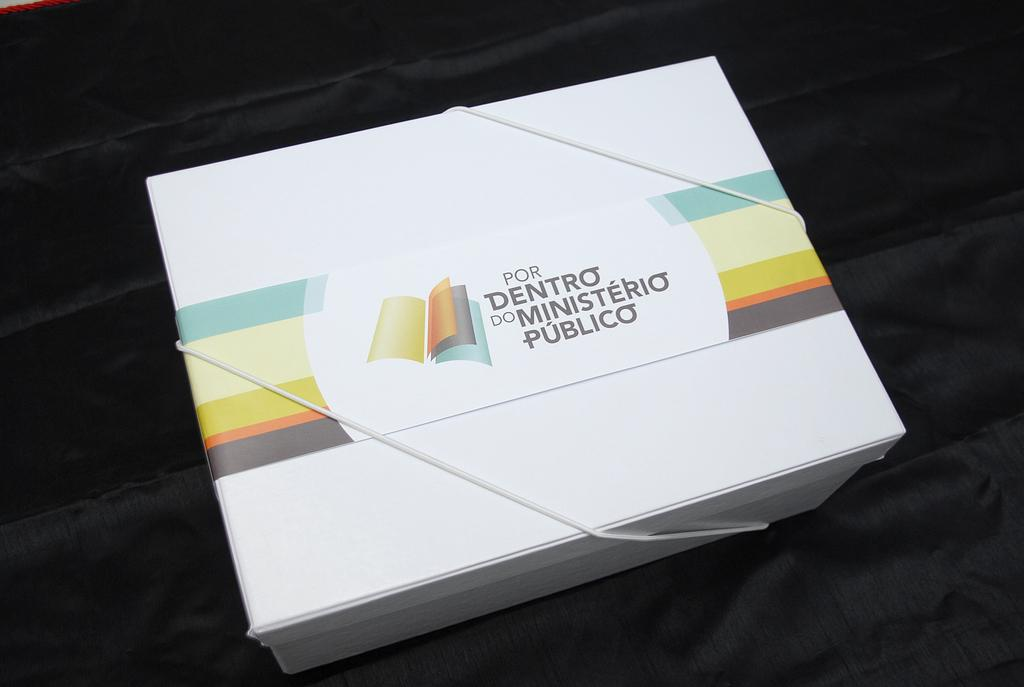<image>
Create a compact narrative representing the image presented. A white box that says Por Dentro Do Ministerio Publico. 